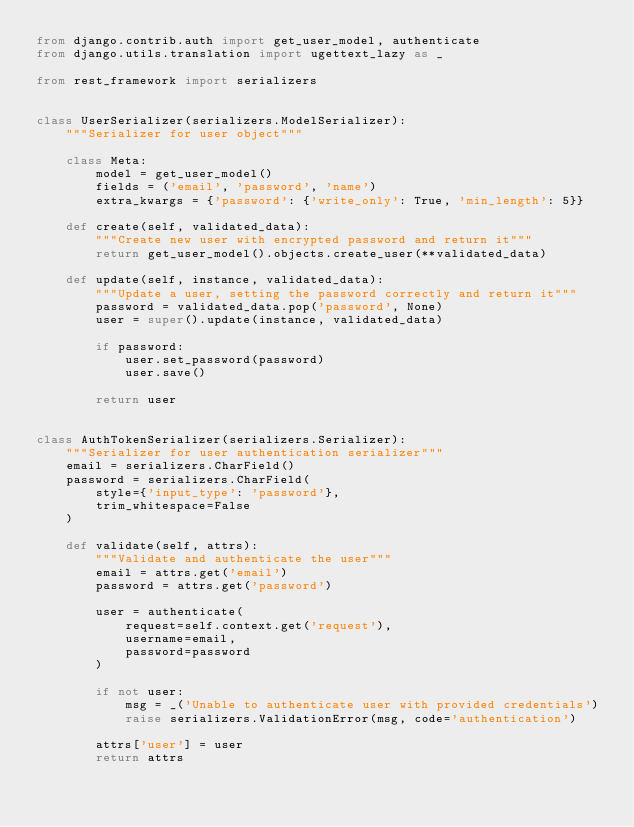Convert code to text. <code><loc_0><loc_0><loc_500><loc_500><_Python_>from django.contrib.auth import get_user_model, authenticate
from django.utils.translation import ugettext_lazy as _

from rest_framework import serializers


class UserSerializer(serializers.ModelSerializer):
    """Serializer for user object"""

    class Meta:
        model = get_user_model()
        fields = ('email', 'password', 'name')
        extra_kwargs = {'password': {'write_only': True, 'min_length': 5}}

    def create(self, validated_data):
        """Create new user with encrypted password and return it"""
        return get_user_model().objects.create_user(**validated_data)

    def update(self, instance, validated_data):
        """Update a user, setting the password correctly and return it"""
        password = validated_data.pop('password', None)
        user = super().update(instance, validated_data)

        if password:
            user.set_password(password)
            user.save()

        return user


class AuthTokenSerializer(serializers.Serializer):
    """Serializer for user authentication serializer"""
    email = serializers.CharField()
    password = serializers.CharField(
        style={'input_type': 'password'},
        trim_whitespace=False
    )

    def validate(self, attrs):
        """Validate and authenticate the user"""
        email = attrs.get('email')
        password = attrs.get('password')

        user = authenticate(
            request=self.context.get('request'),
            username=email,
            password=password
        )

        if not user:
            msg = _('Unable to authenticate user with provided credentials')
            raise serializers.ValidationError(msg, code='authentication')

        attrs['user'] = user
        return attrs
</code> 